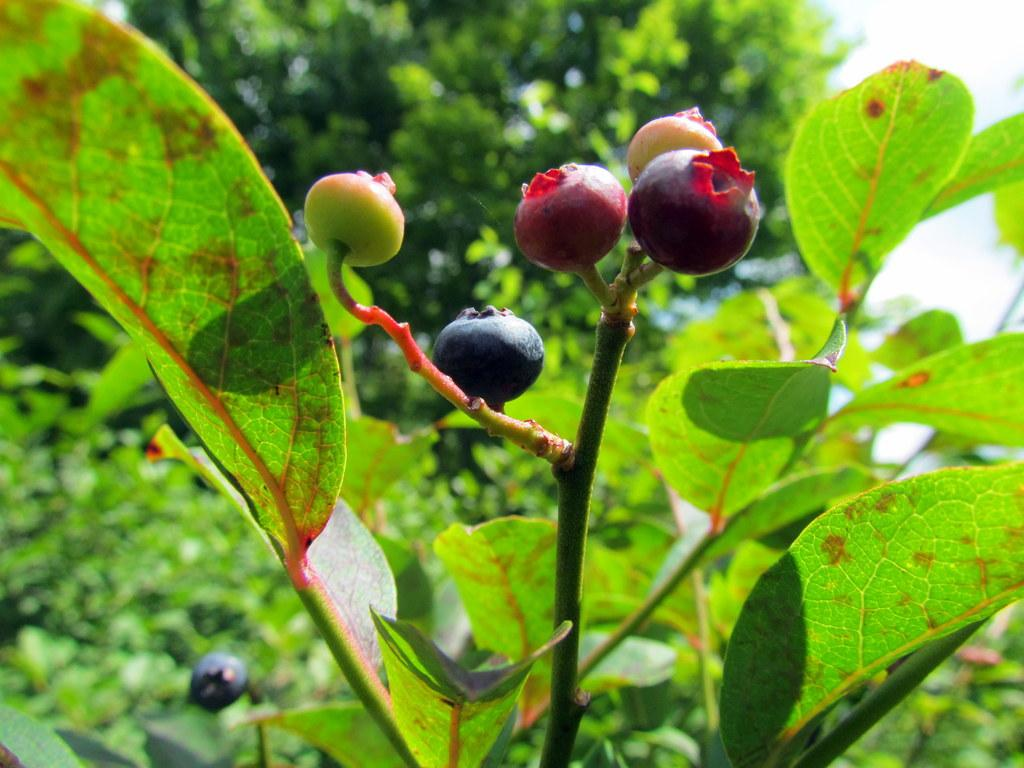What type of fruits can be seen on the plant in the image? There are fruits on the stem of a plant in the image. What else can be seen on the plant besides the fruits? There are leaves visible in the image. What is visible in the background of the image? There is a tree and the sky visible in the background of the image. What type of pain can be heard in the voice of the dolls in the image? There are no dolls present in the image, and therefore no voices or pain can be heard. 